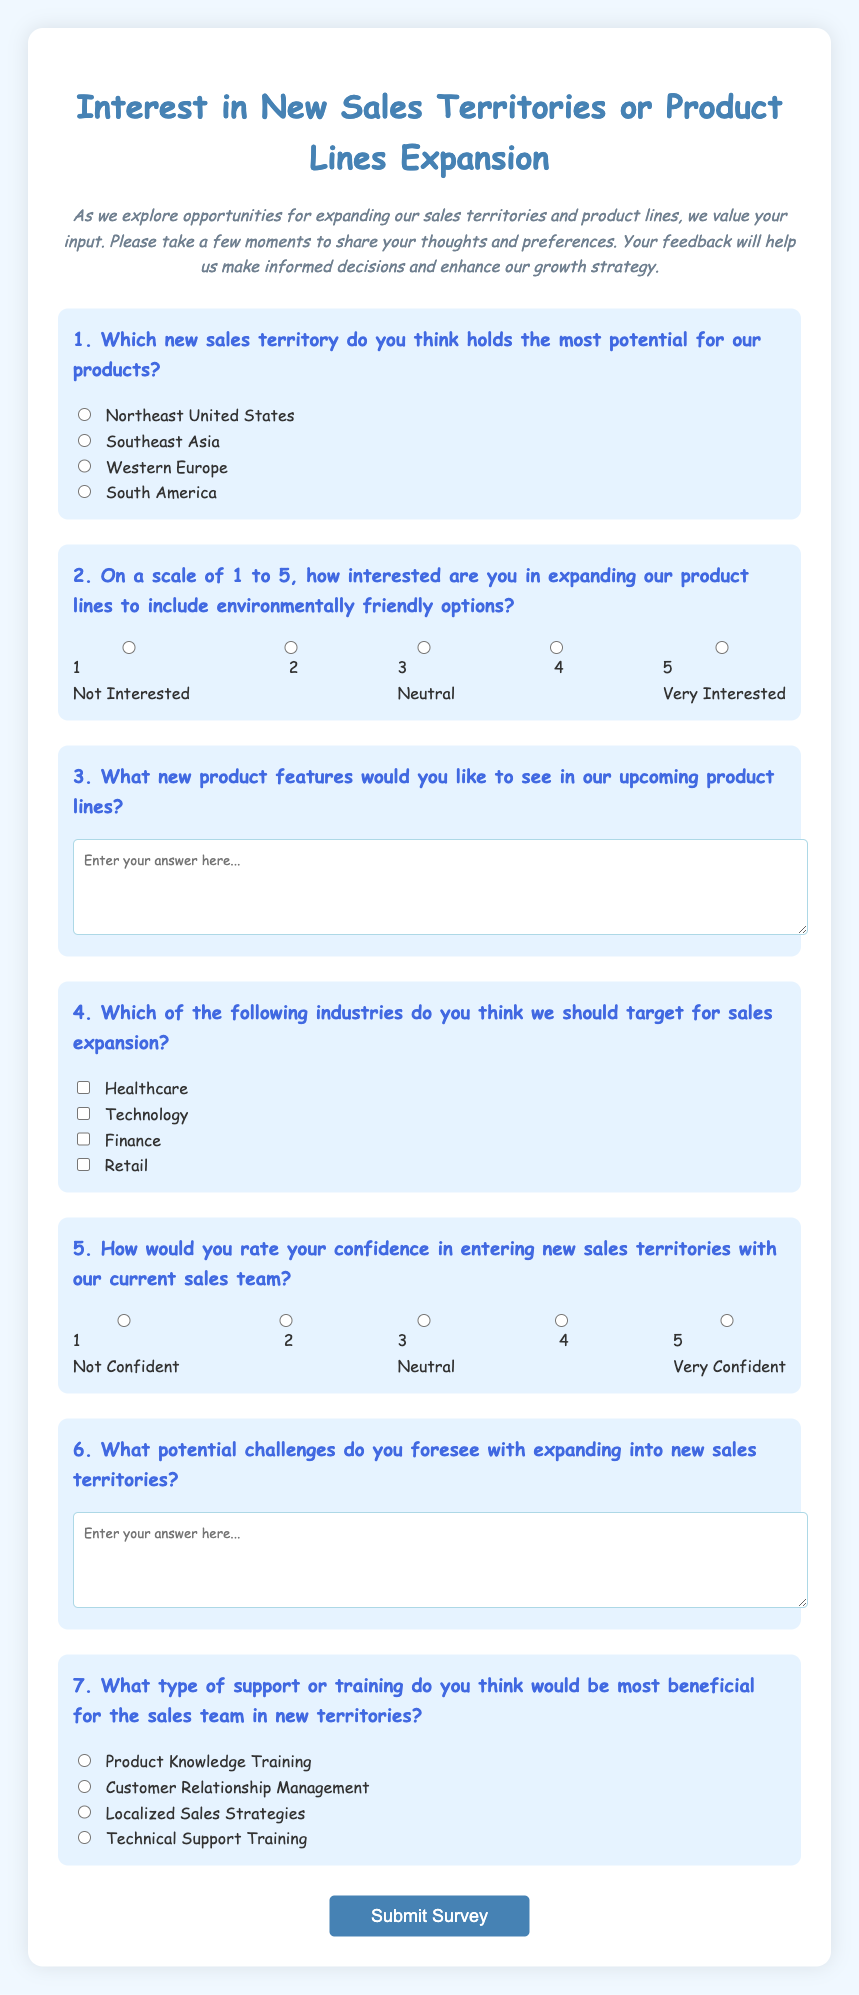What is the title of the survey? The title of the survey is highlighted at the top of the document, stating its purpose clearly.
Answer: Interest in New Sales Territories or Product Lines Expansion How many main questions are in the survey? The number of questions can be counted from the document's structure, and they are numbered sequentially.
Answer: 7 What rating scale is used for gauging interest in environmentally friendly options? The rating is displayed with five different levels, ranging from 1 to 5.
Answer: 1 to 5 Which territory is mentioned as one of the options to select? The options for new sales territories are provided in the document, listing several geographical locations.
Answer: Northeast United States What type of training is mentioned as a support option for the sales team? The document lists specific training types within the survey related to sales team support in new territories.
Answer: Product Knowledge Training What is required to submit the survey? The submission method is indicated by the button labeled within the form for users to complete the survey.
Answer: Submit Survey What is the purpose of this survey? The purpose is indicated in the introductory paragraph, explaining the goal of collecting feedback for decision-making.
Answer: To gather feedback on expanding sales territories and product lines 